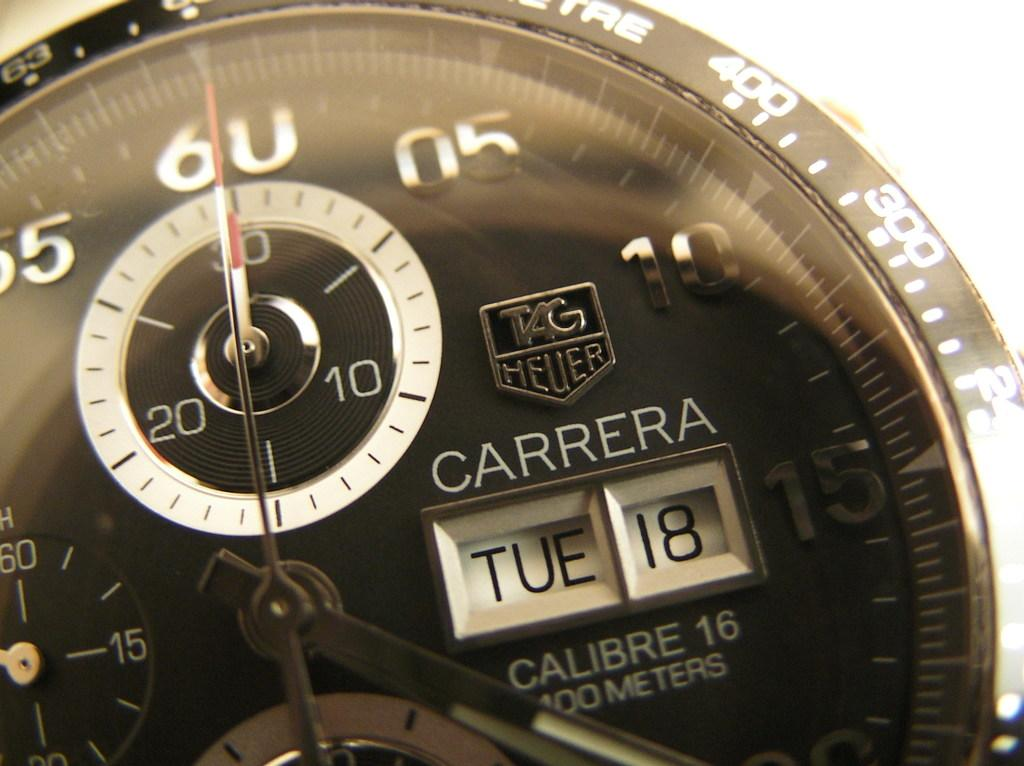<image>
Create a compact narrative representing the image presented. The date on a watch is set to Tuesday the 18th. 